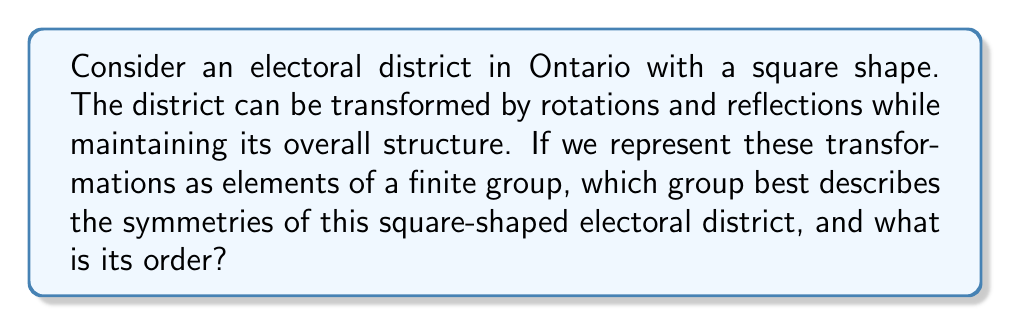Teach me how to tackle this problem. To solve this problem, let's approach it step-by-step using concepts from representation theory and group theory:

1) First, we need to identify all the symmetries of a square:
   - 4 rotations (0°, 90°, 180°, 270°)
   - 4 reflections (2 diagonal, 2 across midpoints of sides)

2) These 8 symmetries form a group under composition. This group is known as the dihedral group of order 8, denoted as $D_4$ or $D_8$ (depending on the notation system).

3) The group $D_4$ has the following properties:
   - It is non-abelian (rotations and reflections don't always commute)
   - It has 8 elements
   - It can be generated by two elements: a 90° rotation and a reflection

4) In terms of representation theory, we can represent these transformations as 2x2 matrices:
   - Rotation by 90°: $R = \begin{pmatrix} 0 & -1 \\ 1 & 0 \end{pmatrix}$
   - Reflection across y-axis: $S = \begin{pmatrix} -1 & 0 \\ 0 & 1 \end{pmatrix}$

5) All other elements of the group can be generated by combinations of $R$ and $S$.

6) This representation allows us to study how the symmetries of the electoral district interact and compose, which is crucial for understanding the overall symmetry of the district.

7) The order of the group is the total number of unique elements, which in this case is 8.
Answer: $D_4$ (or $D_8$), order 8 